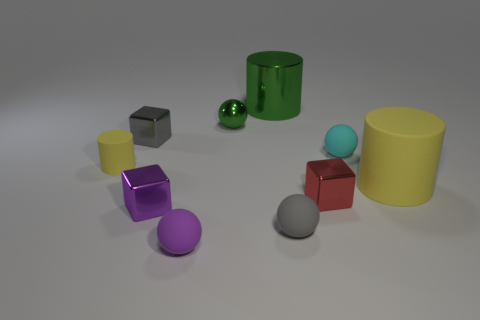Is there a big yellow object of the same shape as the big green shiny thing?
Your answer should be compact. Yes. What number of other things are the same shape as the small purple rubber object?
Offer a very short reply. 3. Is the shape of the tiny yellow object the same as the large thing that is behind the cyan matte thing?
Provide a succinct answer. Yes. Are there any other things that are made of the same material as the small cyan ball?
Keep it short and to the point. Yes. What is the material of the purple object that is the same shape as the red shiny object?
Your answer should be very brief. Metal. How many big objects are gray balls or purple rubber balls?
Offer a very short reply. 0. Are there fewer tiny purple cubes that are on the right side of the small purple matte sphere than objects to the left of the cyan sphere?
Your answer should be very brief. Yes. How many objects are brown spheres or gray rubber things?
Give a very brief answer. 1. How many matte cylinders are to the left of the small purple shiny object?
Your response must be concise. 1. Do the large metallic cylinder and the metallic ball have the same color?
Your answer should be very brief. Yes. 